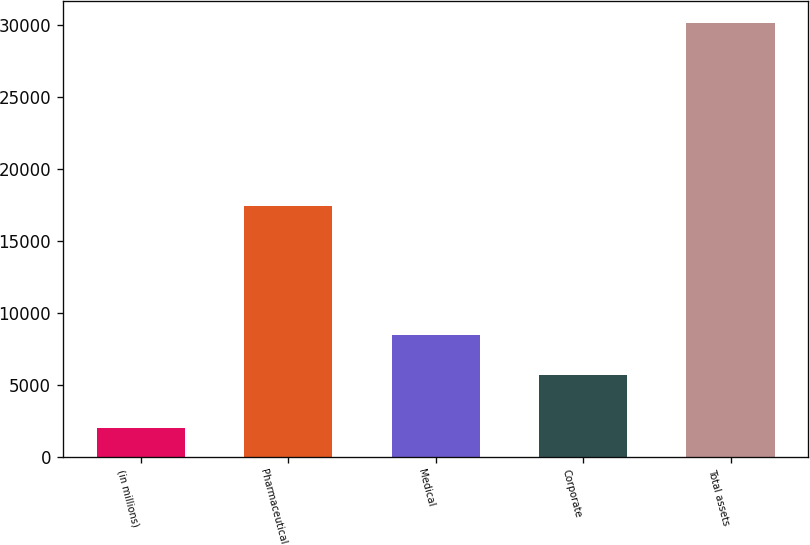Convert chart. <chart><loc_0><loc_0><loc_500><loc_500><bar_chart><fcel>(in millions)<fcel>Pharmaceutical<fcel>Medical<fcel>Corporate<fcel>Total assets<nl><fcel>2015<fcel>17385<fcel>8474.7<fcel>5662<fcel>30142<nl></chart> 